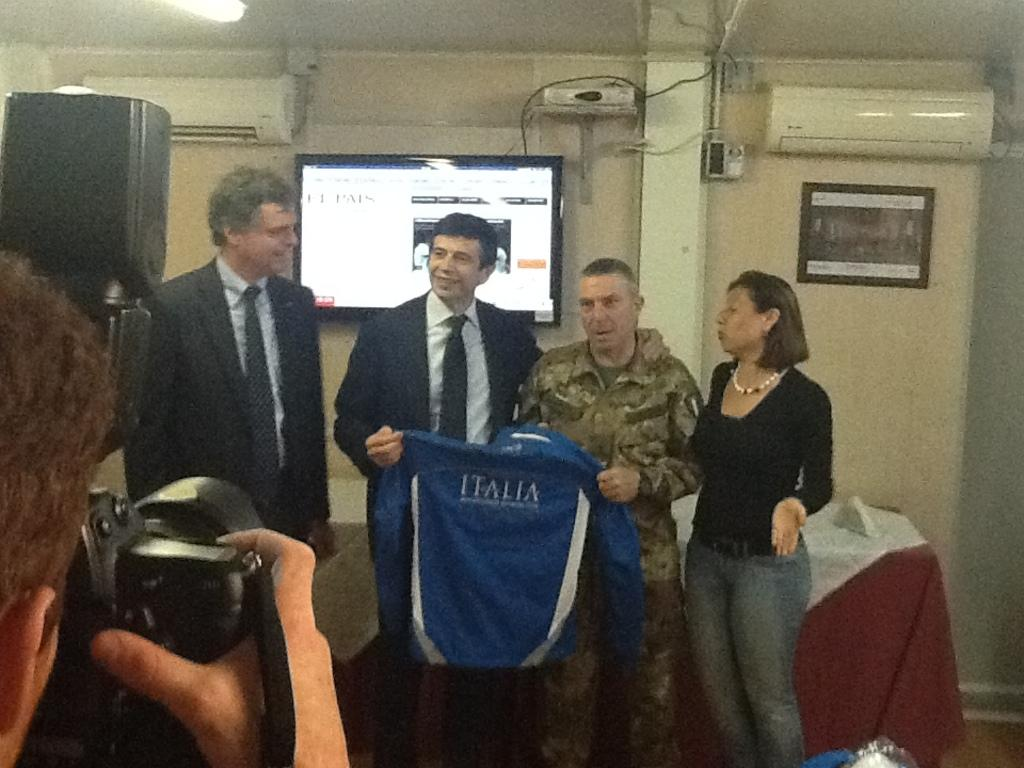What type of structure can be seen in the image? There is a wall in the image. What is hanging on the wall? There are photo frames in the image. What device is present for cooling the room? There is an air conditioner in the image. What electronic device is visible in the image? There is a television in the image. Are there any people present in the image? Yes, there are people standing in the image. What is the man on the left side holding? The man on the left side is holding a camera. What is the shape of the afterthought in the image? There is no afterthought present in the image. What type of noise can be heard coming from the square in the image? There is no square or noise present in the image. 